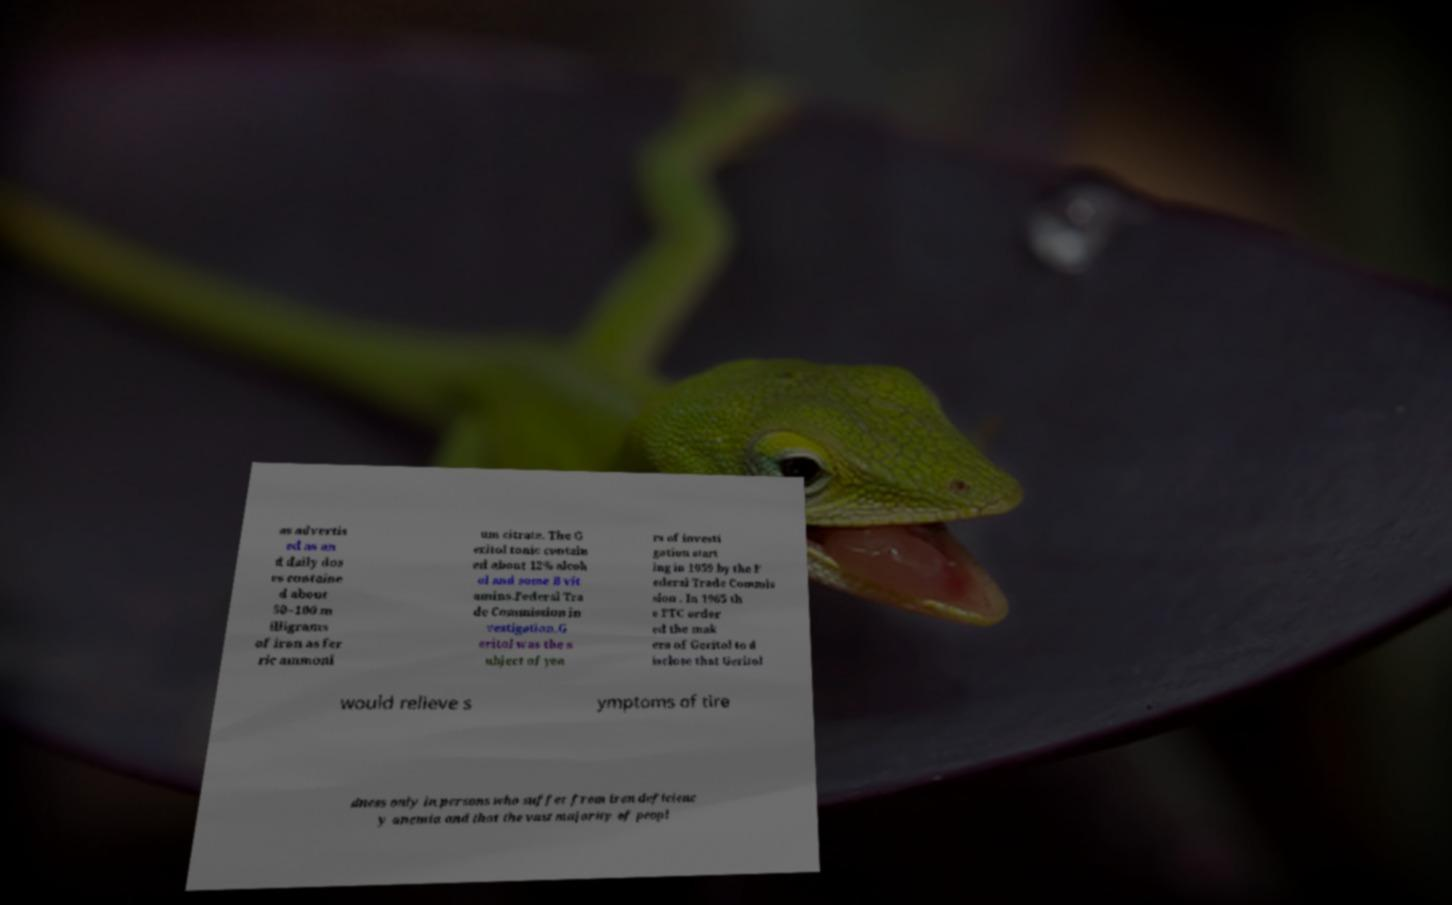For documentation purposes, I need the text within this image transcribed. Could you provide that? as advertis ed as an d daily dos es containe d about 50–100 m illigrams of iron as fer ric ammoni um citrate. The G eritol tonic contain ed about 12% alcoh ol and some B vit amins.Federal Tra de Commission in vestigation.G eritol was the s ubject of yea rs of investi gation start ing in 1959 by the F ederal Trade Commis sion . In 1965 th e FTC order ed the mak ers of Geritol to d isclose that Geritol would relieve s ymptoms of tire dness only in persons who suffer from iron deficienc y anemia and that the vast majority of peopl 